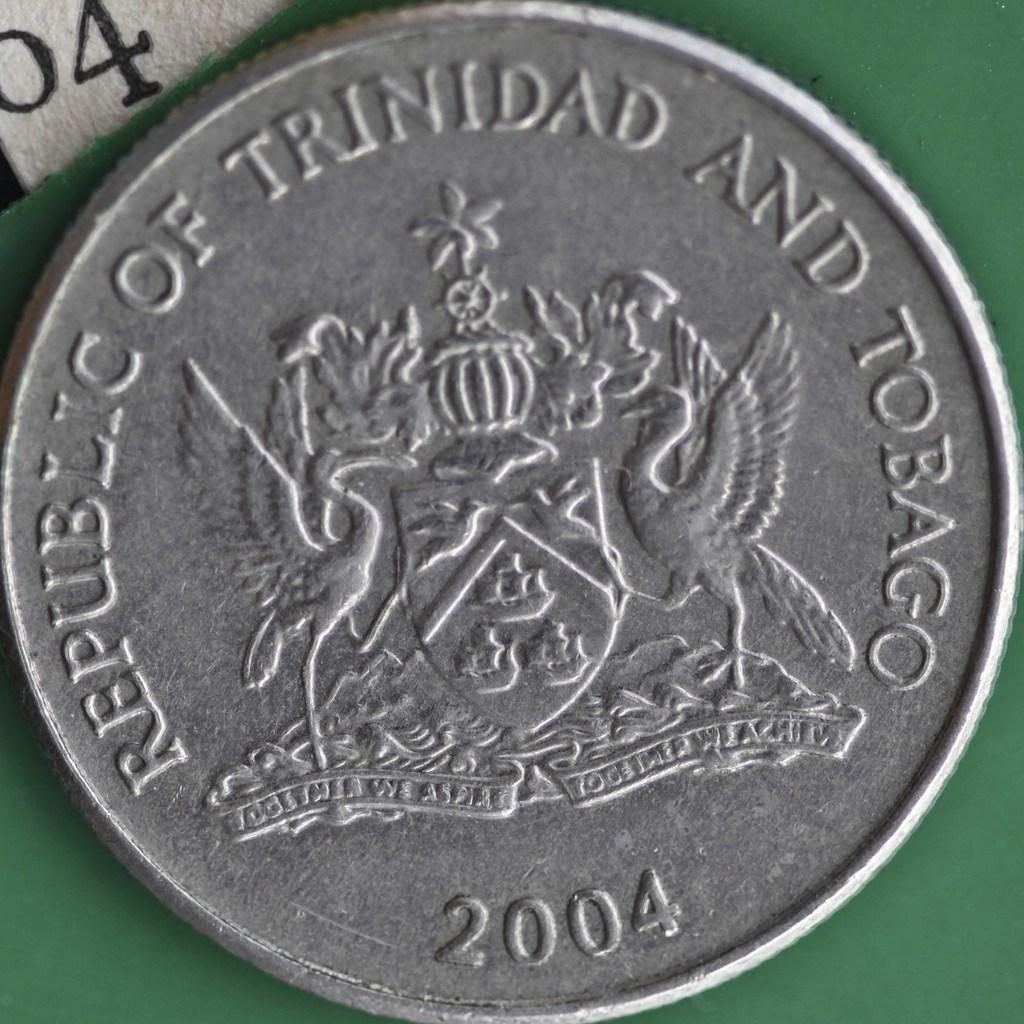Provide a one-sentence caption for the provided image. A silver Trinidad and Tobago coin was minted in 2004. 